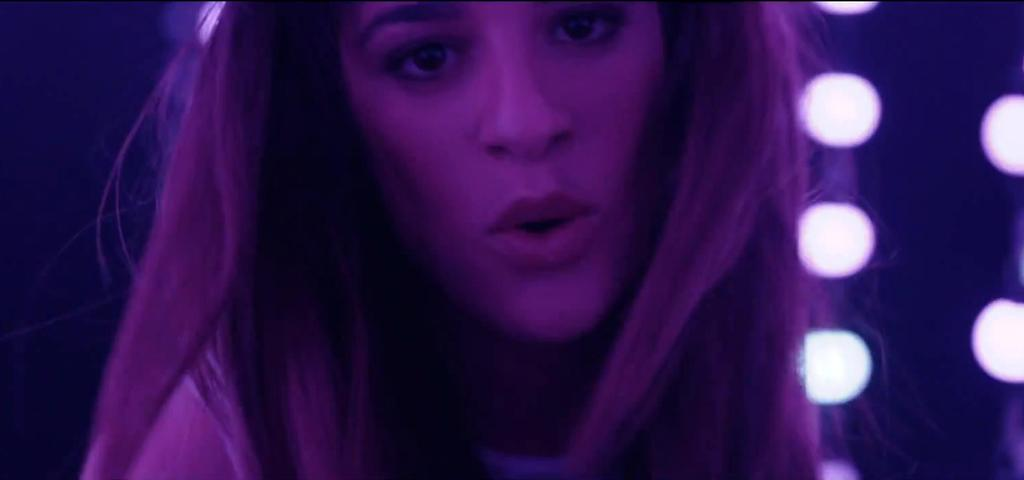Who is present in the image? There is a lady in the image. Where is the lady located in the image? The lady is in the background of the image. What else can be seen in the image besides the lady? There are lights visible in the image. What type of harmony is being played by the cabbage in the image? There is no cabbage present in the image, and therefore no music or harmony can be observed. 